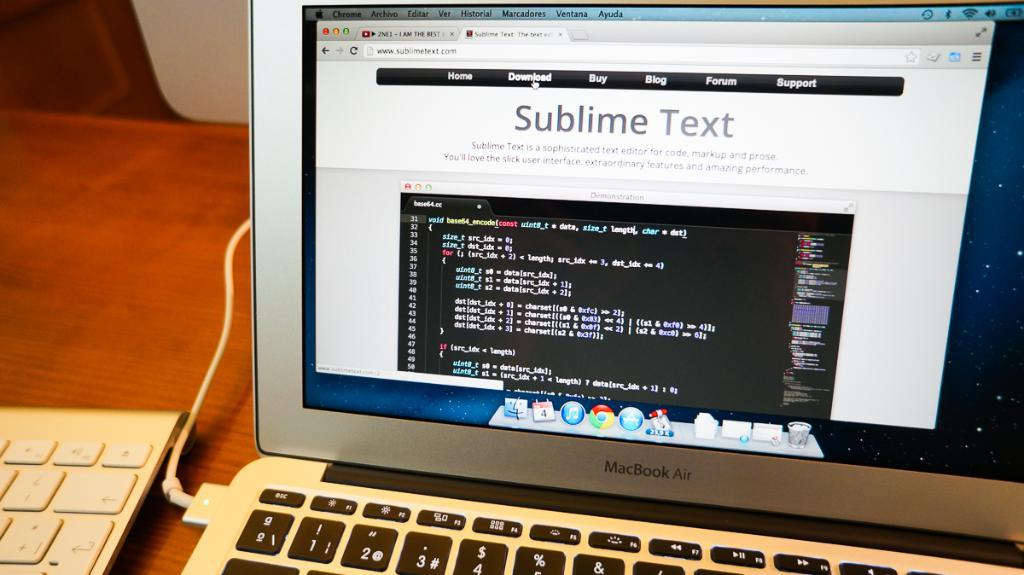<image>
Summarize the visual content of the image. Computer screen that says Sublime Text on it next to a keyboard. 